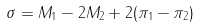<formula> <loc_0><loc_0><loc_500><loc_500>\sigma = M _ { 1 } - 2 M _ { 2 } + 2 ( \pi _ { 1 } - \pi _ { 2 } )</formula> 